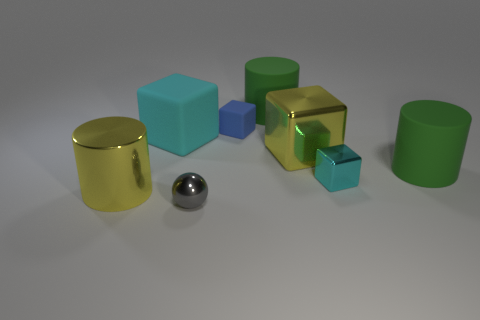Can you describe the lighting in the scene? The lighting appears to be coming from above and creates soft shadows on the ground below the objects, suggesting a diffuse light source, possibly to simulate an indoor environment. 